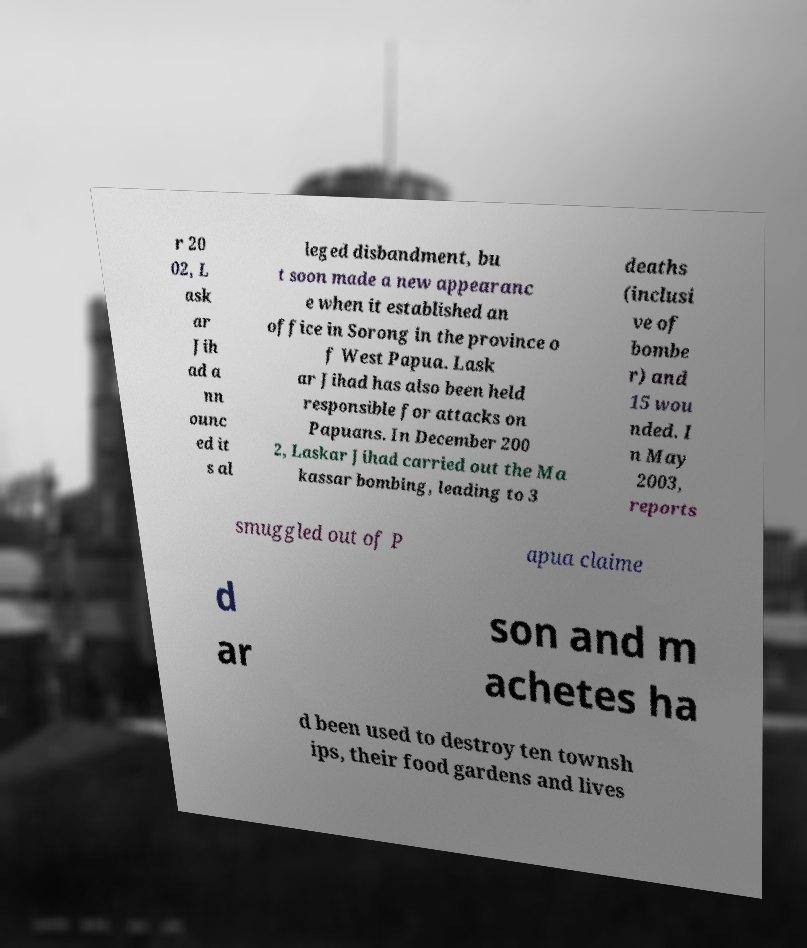Please identify and transcribe the text found in this image. r 20 02, L ask ar Jih ad a nn ounc ed it s al leged disbandment, bu t soon made a new appearanc e when it established an office in Sorong in the province o f West Papua. Lask ar Jihad has also been held responsible for attacks on Papuans. In December 200 2, Laskar Jihad carried out the Ma kassar bombing, leading to 3 deaths (inclusi ve of bombe r) and 15 wou nded. I n May 2003, reports smuggled out of P apua claime d ar son and m achetes ha d been used to destroy ten townsh ips, their food gardens and lives 